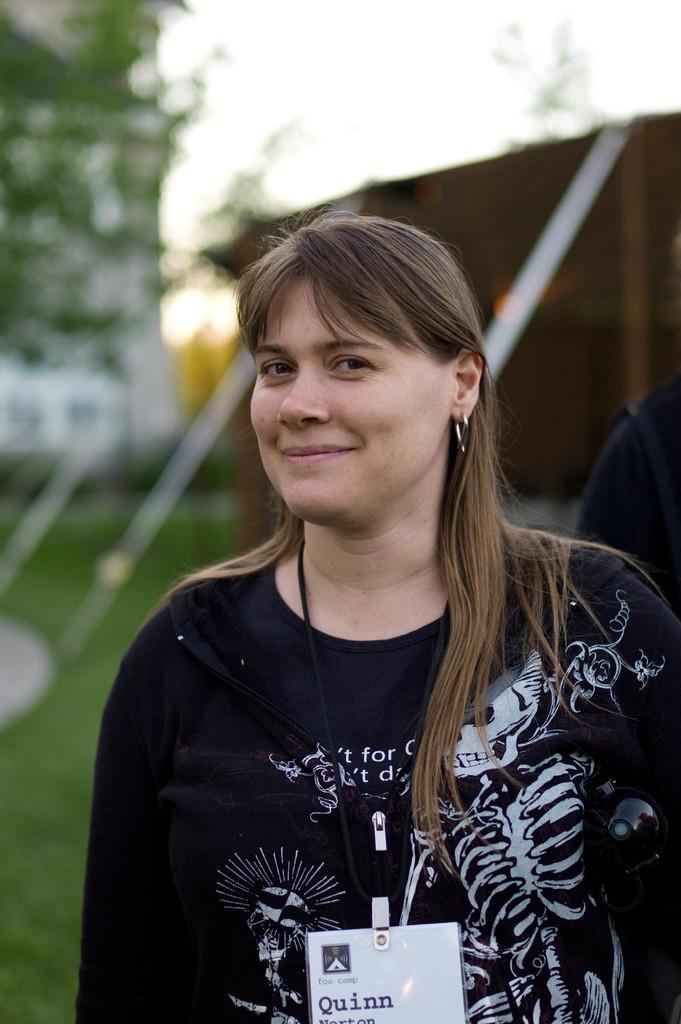What is the main subject in the foreground of the image? There is a girl in the foreground of the image. What is the girl wearing in the image? The girl is wearing an ID card in the image. How is the background of the girl depicted in the image? The background of the girl is blurred in the image. What type of division is taking place in the image? There is no division taking place in the image; it is a picture of a girl wearing an ID card with a blurred background. Can you see any cannons in the image? There are no cannons present in the image. 